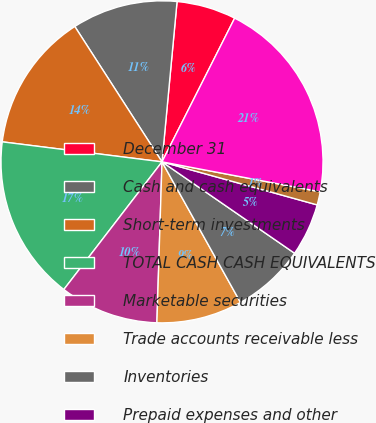Convert chart to OTSL. <chart><loc_0><loc_0><loc_500><loc_500><pie_chart><fcel>December 31<fcel>Cash and cash equivalents<fcel>Short-term investments<fcel>TOTAL CASH CASH EQUIVALENTS<fcel>Marketable securities<fcel>Trade accounts receivable less<fcel>Inventories<fcel>Prepaid expenses and other<fcel>Assets held for sale<fcel>TOTAL CURRENT ASSETS<nl><fcel>5.96%<fcel>10.6%<fcel>13.91%<fcel>16.55%<fcel>9.93%<fcel>8.61%<fcel>7.29%<fcel>5.3%<fcel>1.33%<fcel>20.53%<nl></chart> 